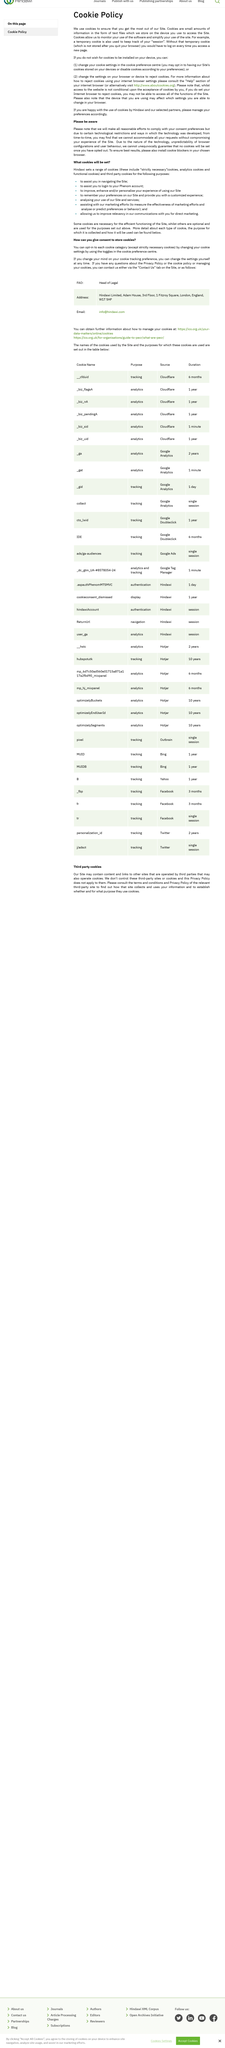Mention a couple of crucial points in this snapshot. Hindawi uses a variety of cookies for different purposes. It is possible to decline the installation of the Site's cookies on your device. Setting your internet browser to reject cookies may prevent you from accessing all functions of the website. Yes, cookies can assist in navigating the site. Cookies are data files stored on devices used to access a website. 